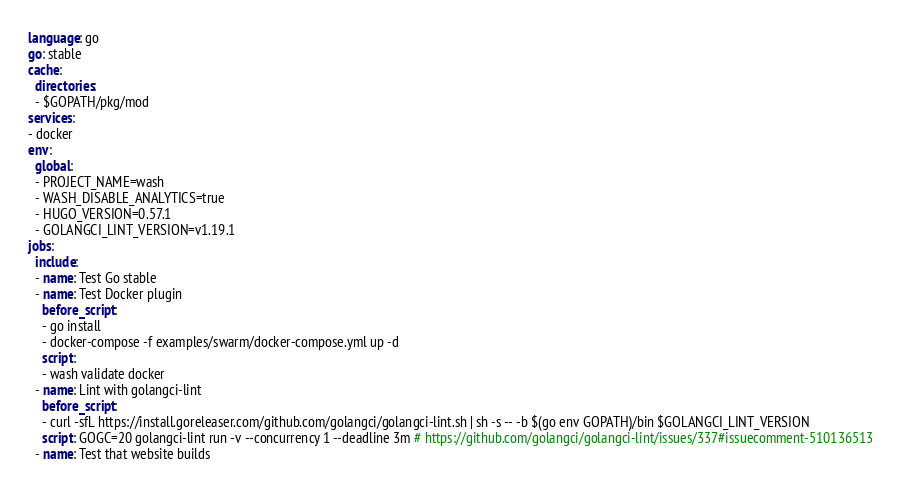<code> <loc_0><loc_0><loc_500><loc_500><_YAML_>language: go
go: stable
cache:
  directories:
  - $GOPATH/pkg/mod
services:
- docker
env:
  global:
  - PROJECT_NAME=wash
  - WASH_DISABLE_ANALYTICS=true
  - HUGO_VERSION=0.57.1
  - GOLANGCI_LINT_VERSION=v1.19.1
jobs:
  include:
  - name: Test Go stable
  - name: Test Docker plugin
    before_script:
    - go install
    - docker-compose -f examples/swarm/docker-compose.yml up -d
    script:
    - wash validate docker
  - name: Lint with golangci-lint
    before_script:
    - curl -sfL https://install.goreleaser.com/github.com/golangci/golangci-lint.sh | sh -s -- -b $(go env GOPATH)/bin $GOLANGCI_LINT_VERSION
    script: GOGC=20 golangci-lint run -v --concurrency 1 --deadline 3m # https://github.com/golangci/golangci-lint/issues/337#issuecomment-510136513
  - name: Test that website builds</code> 